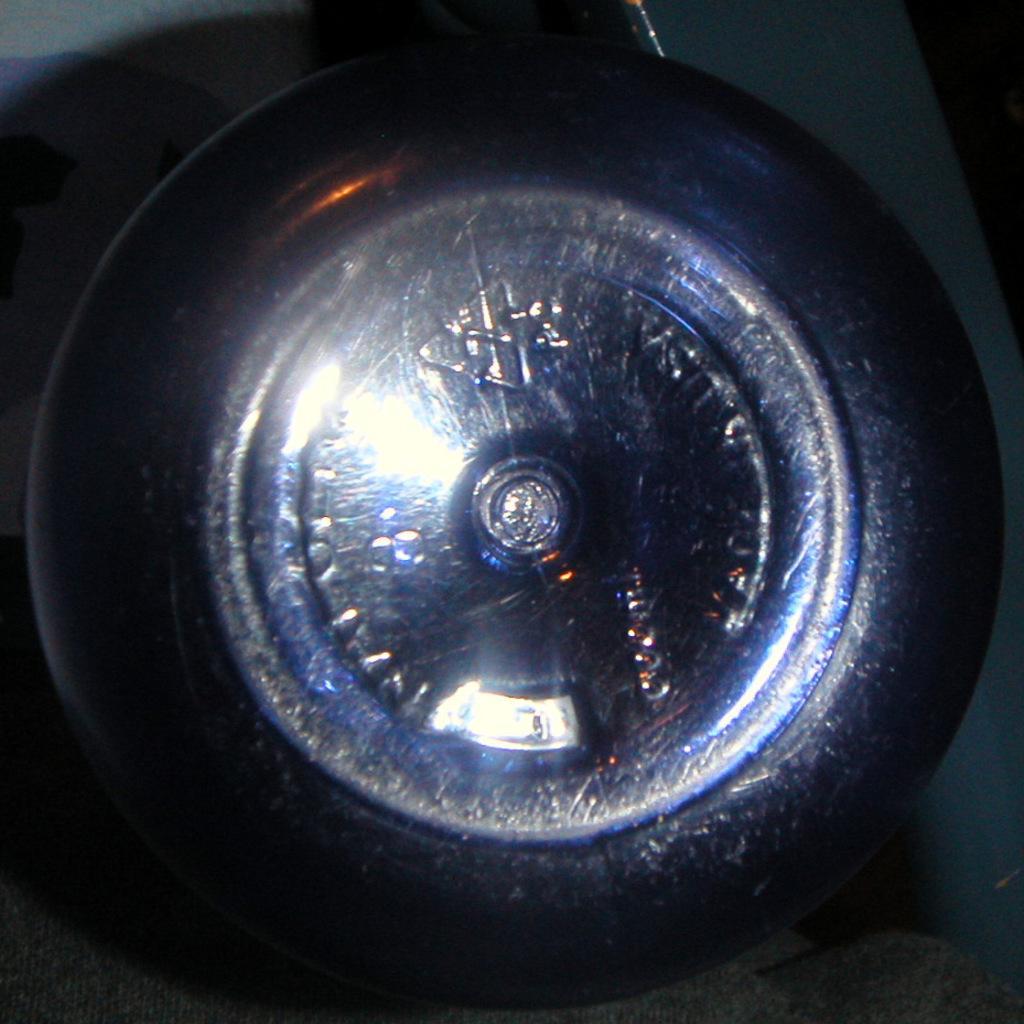How would you summarize this image in a sentence or two? There is a black color tie with a alloy. 